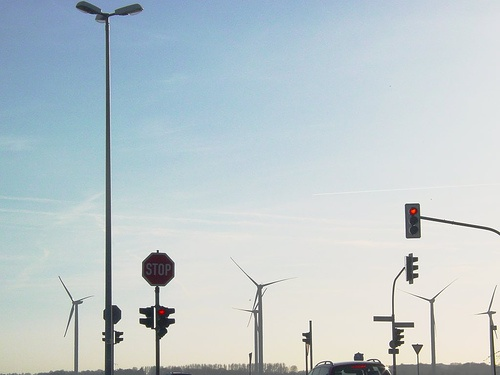Describe the objects in this image and their specific colors. I can see stop sign in gray and black tones, car in gray, black, ivory, and darkgray tones, traffic light in gray, black, and maroon tones, traffic light in gray, black, lightgray, and maroon tones, and traffic light in gray and black tones in this image. 